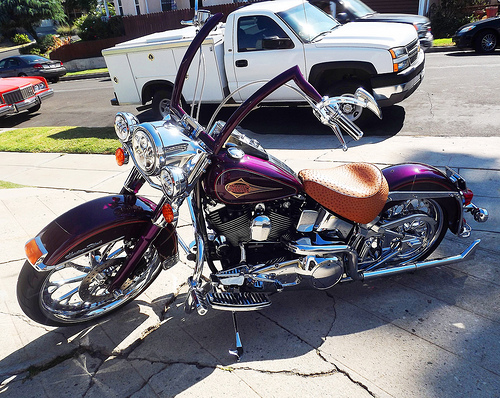<image>
Is there a bike behind the truck? No. The bike is not behind the truck. From this viewpoint, the bike appears to be positioned elsewhere in the scene. Is there a bike to the right of the car? No. The bike is not to the right of the car. The horizontal positioning shows a different relationship. 